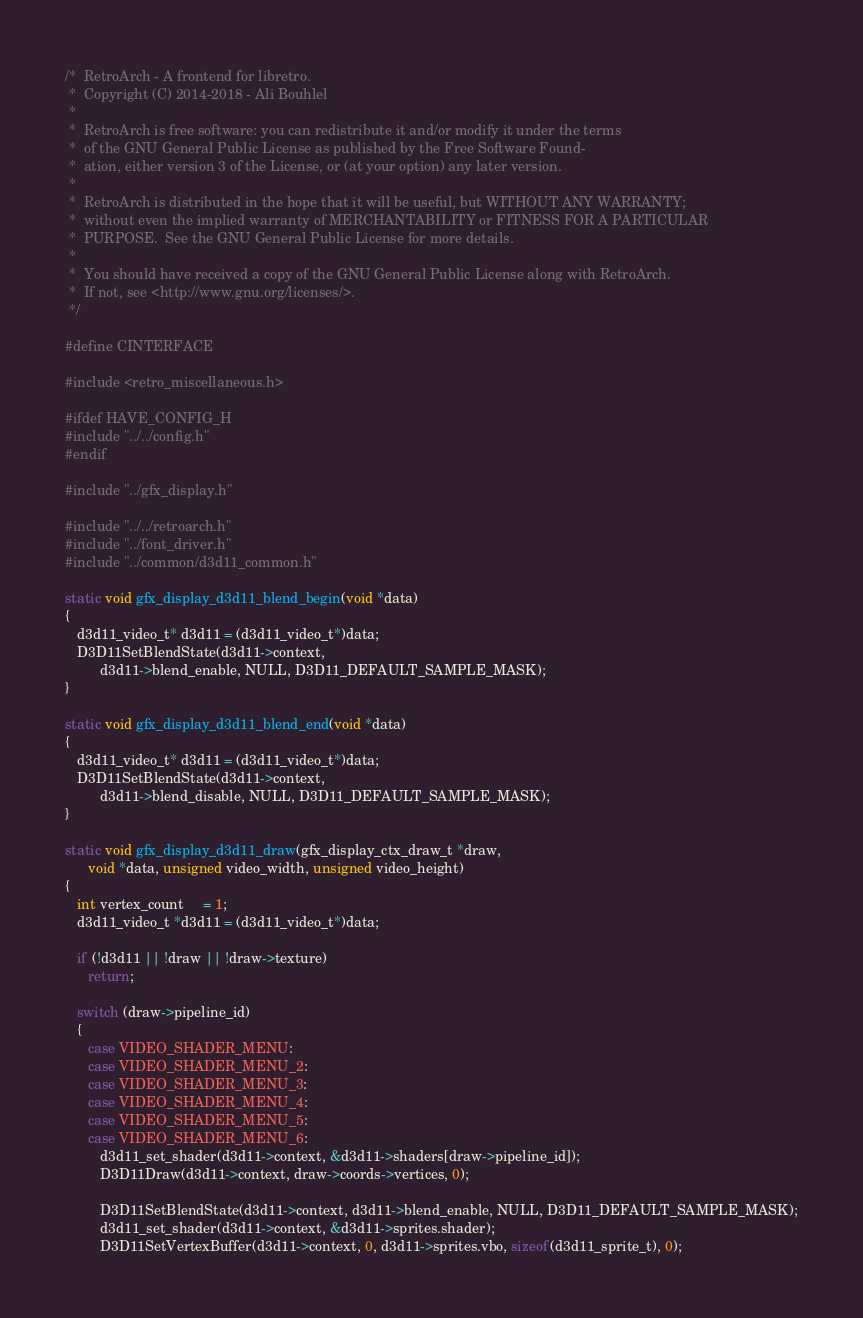<code> <loc_0><loc_0><loc_500><loc_500><_C_>/*  RetroArch - A frontend for libretro.
 *  Copyright (C) 2014-2018 - Ali Bouhlel
 *
 *  RetroArch is free software: you can redistribute it and/or modify it under the terms
 *  of the GNU General Public License as published by the Free Software Found-
 *  ation, either version 3 of the License, or (at your option) any later version.
 *
 *  RetroArch is distributed in the hope that it will be useful, but WITHOUT ANY WARRANTY;
 *  without even the implied warranty of MERCHANTABILITY or FITNESS FOR A PARTICULAR
 *  PURPOSE.  See the GNU General Public License for more details.
 *
 *  You should have received a copy of the GNU General Public License along with RetroArch.
 *  If not, see <http://www.gnu.org/licenses/>.
 */

#define CINTERFACE

#include <retro_miscellaneous.h>

#ifdef HAVE_CONFIG_H
#include "../../config.h"
#endif

#include "../gfx_display.h"

#include "../../retroarch.h"
#include "../font_driver.h"
#include "../common/d3d11_common.h"

static void gfx_display_d3d11_blend_begin(void *data)
{
   d3d11_video_t* d3d11 = (d3d11_video_t*)data;
   D3D11SetBlendState(d3d11->context,
         d3d11->blend_enable, NULL, D3D11_DEFAULT_SAMPLE_MASK);
}

static void gfx_display_d3d11_blend_end(void *data)
{
   d3d11_video_t* d3d11 = (d3d11_video_t*)data;
   D3D11SetBlendState(d3d11->context,
         d3d11->blend_disable, NULL, D3D11_DEFAULT_SAMPLE_MASK);
}

static void gfx_display_d3d11_draw(gfx_display_ctx_draw_t *draw,
      void *data, unsigned video_width, unsigned video_height)
{
   int vertex_count     = 1;
   d3d11_video_t *d3d11 = (d3d11_video_t*)data;

   if (!d3d11 || !draw || !draw->texture)
      return;

   switch (draw->pipeline_id)
   {
      case VIDEO_SHADER_MENU:
      case VIDEO_SHADER_MENU_2:
      case VIDEO_SHADER_MENU_3:
      case VIDEO_SHADER_MENU_4:
      case VIDEO_SHADER_MENU_5:
      case VIDEO_SHADER_MENU_6:
         d3d11_set_shader(d3d11->context, &d3d11->shaders[draw->pipeline_id]);
         D3D11Draw(d3d11->context, draw->coords->vertices, 0);

         D3D11SetBlendState(d3d11->context, d3d11->blend_enable, NULL, D3D11_DEFAULT_SAMPLE_MASK);
         d3d11_set_shader(d3d11->context, &d3d11->sprites.shader);
         D3D11SetVertexBuffer(d3d11->context, 0, d3d11->sprites.vbo, sizeof(d3d11_sprite_t), 0);</code> 